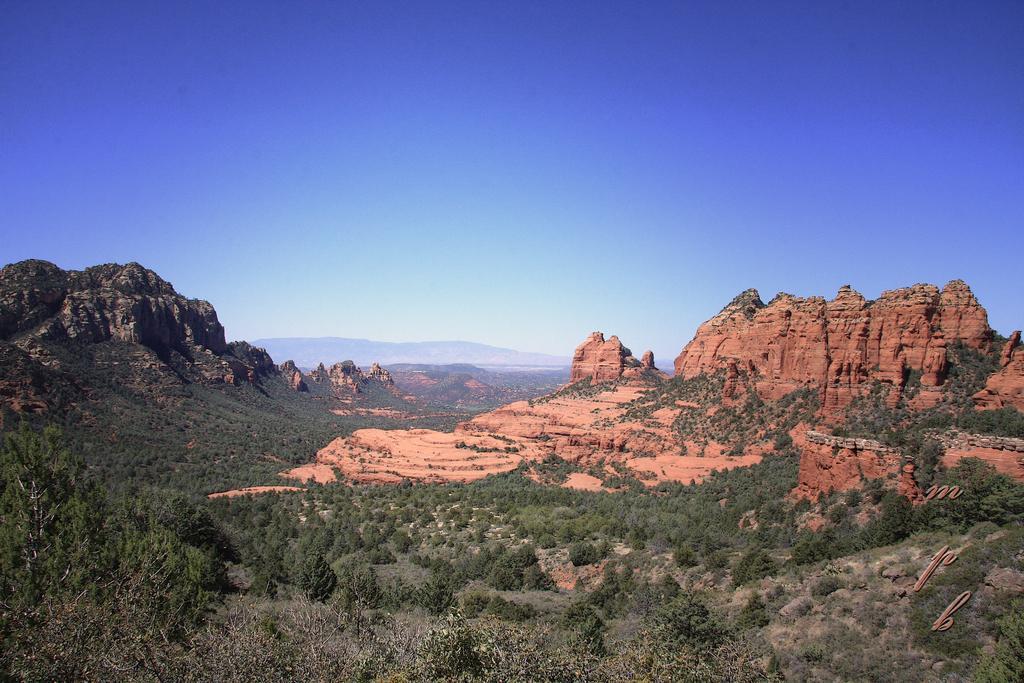Describe this image in one or two sentences. In this picture I can see hills and few trees and I can see blue sky. 